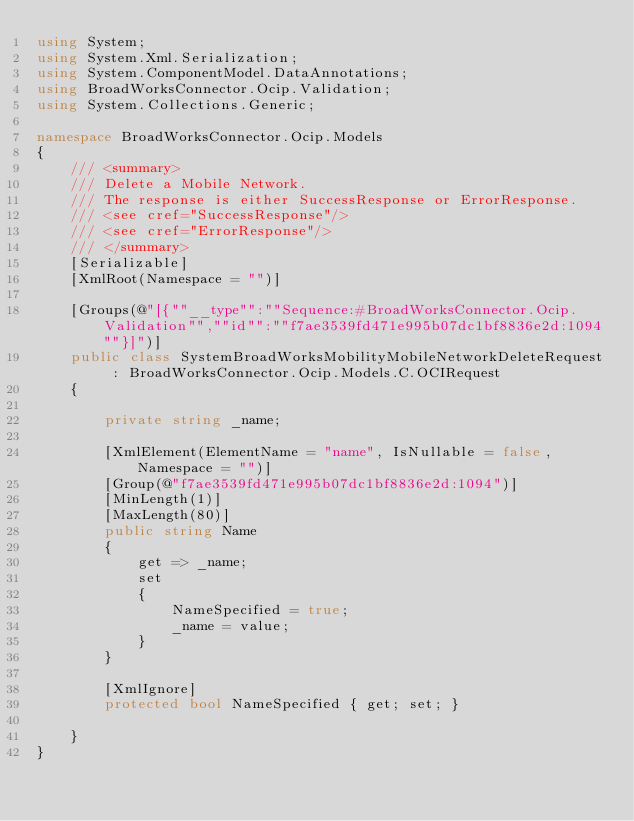<code> <loc_0><loc_0><loc_500><loc_500><_C#_>using System;
using System.Xml.Serialization;
using System.ComponentModel.DataAnnotations;
using BroadWorksConnector.Ocip.Validation;
using System.Collections.Generic;

namespace BroadWorksConnector.Ocip.Models
{
    /// <summary>
    /// Delete a Mobile Network.
    /// The response is either SuccessResponse or ErrorResponse.
    /// <see cref="SuccessResponse"/>
    /// <see cref="ErrorResponse"/>
    /// </summary>
    [Serializable]
    [XmlRoot(Namespace = "")]

    [Groups(@"[{""__type"":""Sequence:#BroadWorksConnector.Ocip.Validation"",""id"":""f7ae3539fd471e995b07dc1bf8836e2d:1094""}]")]
    public class SystemBroadWorksMobilityMobileNetworkDeleteRequest : BroadWorksConnector.Ocip.Models.C.OCIRequest
    {

        private string _name;

        [XmlElement(ElementName = "name", IsNullable = false, Namespace = "")]
        [Group(@"f7ae3539fd471e995b07dc1bf8836e2d:1094")]
        [MinLength(1)]
        [MaxLength(80)]
        public string Name
        {
            get => _name;
            set
            {
                NameSpecified = true;
                _name = value;
            }
        }

        [XmlIgnore]
        protected bool NameSpecified { get; set; }

    }
}
</code> 